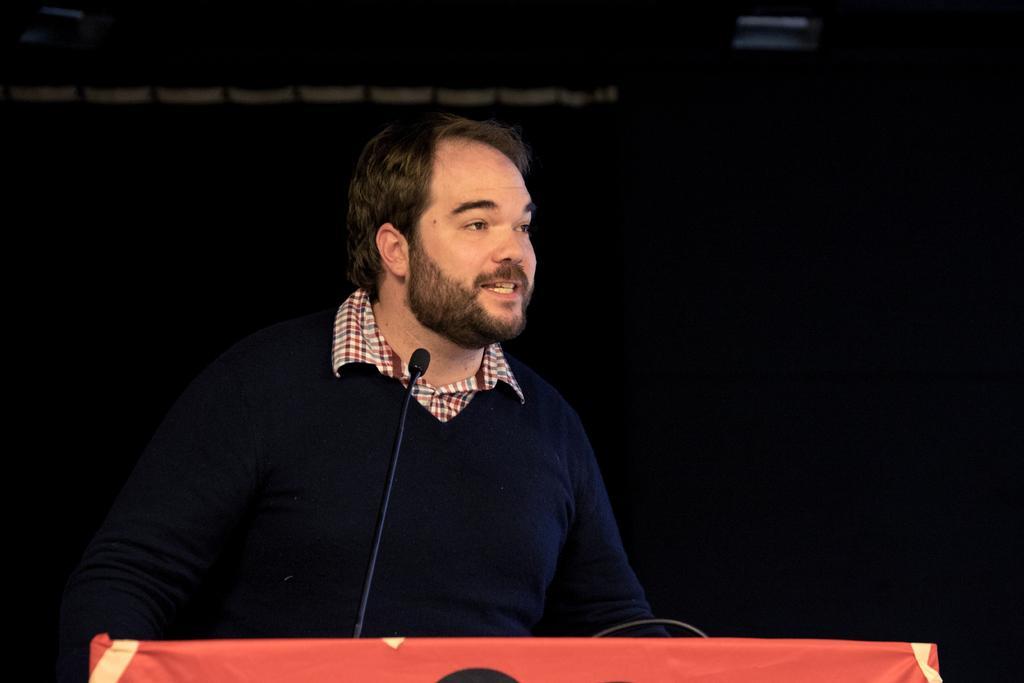Describe this image in one or two sentences. In this picture I can see there is a man standing and speaking and there is a table with a microphone and the backdrop is dark. 